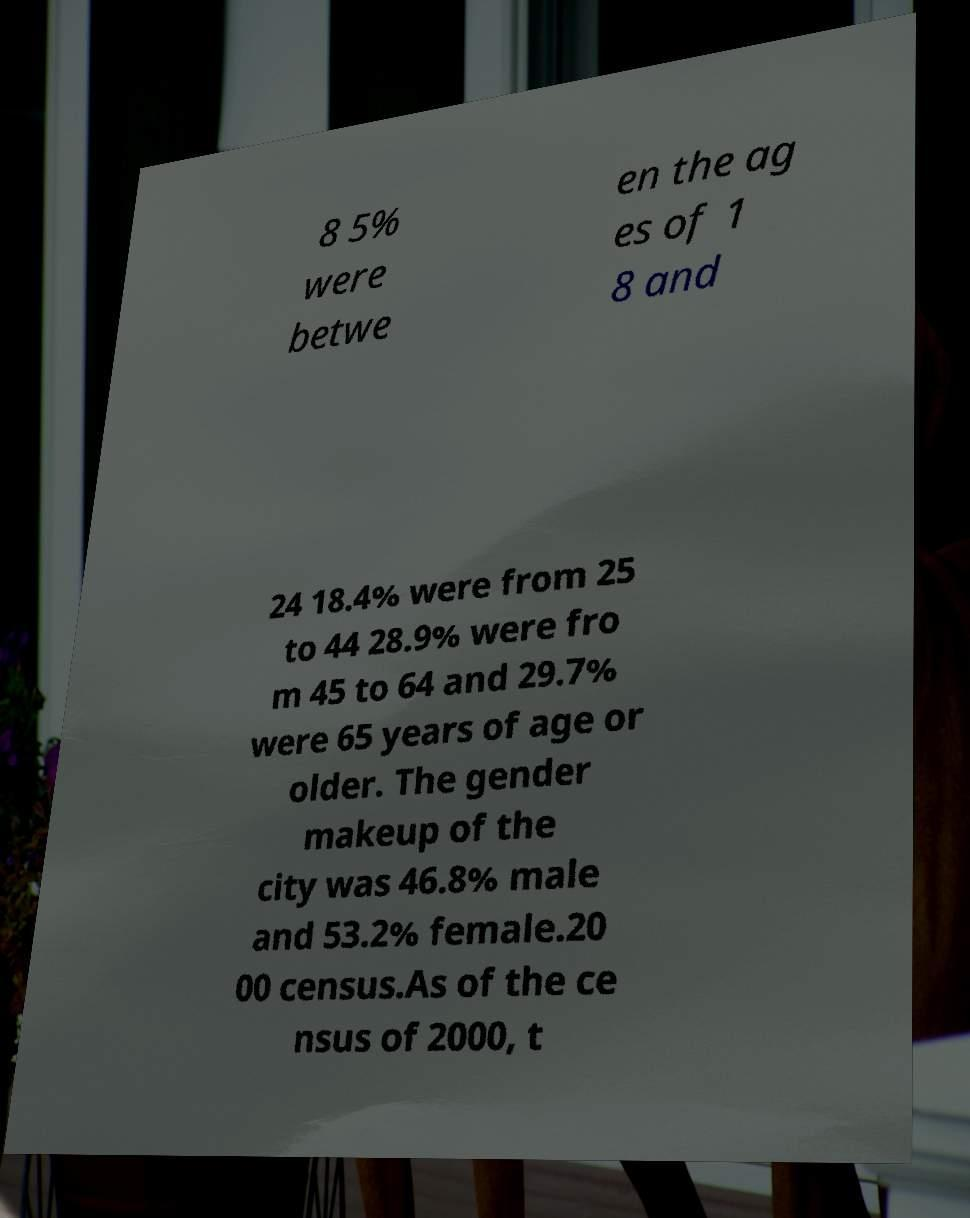Could you assist in decoding the text presented in this image and type it out clearly? 8 5% were betwe en the ag es of 1 8 and 24 18.4% were from 25 to 44 28.9% were fro m 45 to 64 and 29.7% were 65 years of age or older. The gender makeup of the city was 46.8% male and 53.2% female.20 00 census.As of the ce nsus of 2000, t 